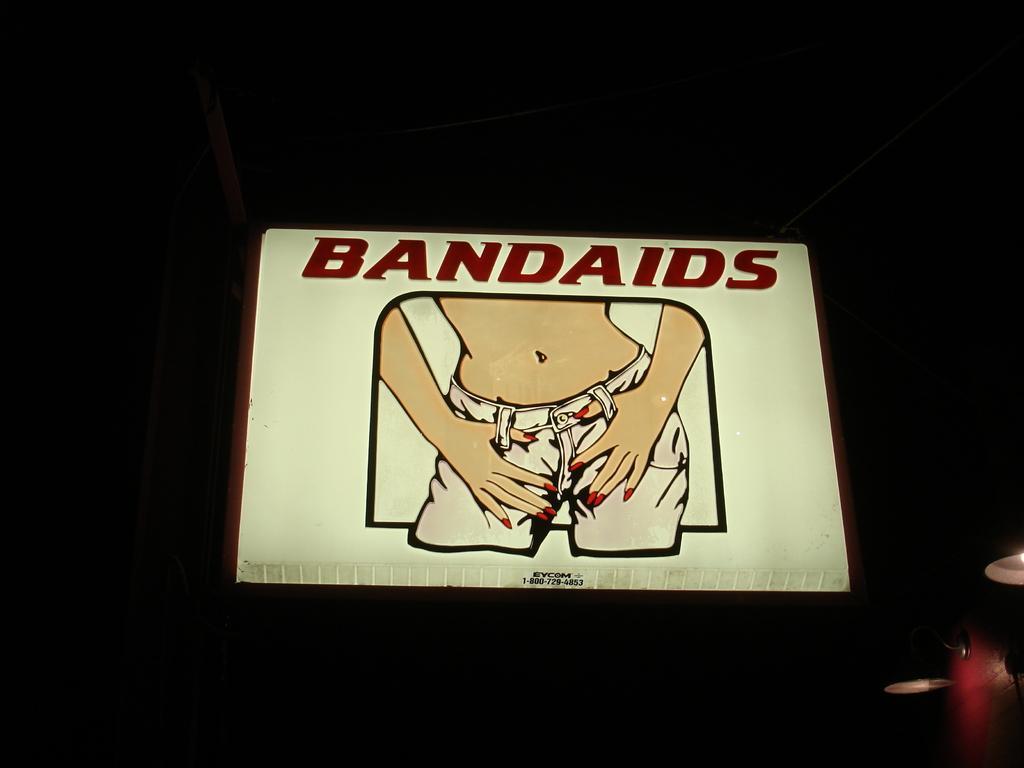How would you summarize this image in a sentence or two? In the center of the image, we can see a board and there is some text written on it and we can see some objects and the background is dark. 